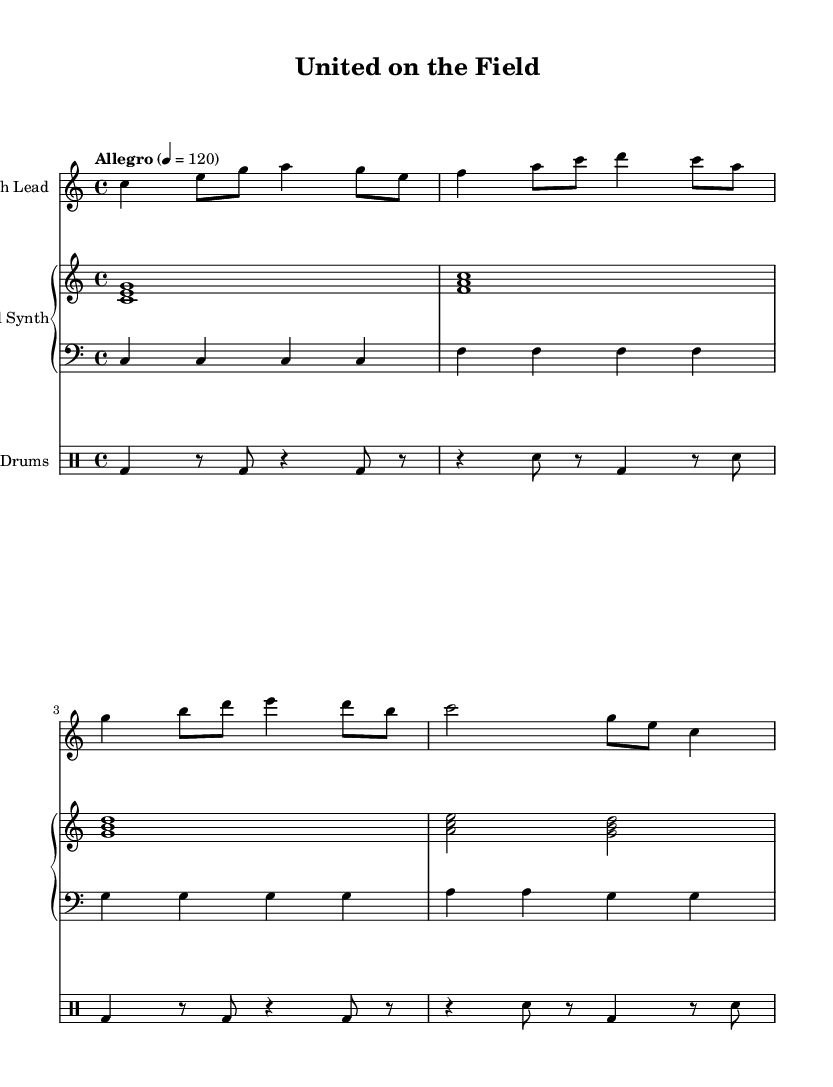What is the key signature of this music? The key signature is C major, which indicates there are no sharps or flats in the music. You can identify this by looking at the key signature section at the beginning of the music sheet.
Answer: C major What is the time signature of this composition? The time signature is 4/4, meaning there are four beats in each measure and the quarter note gets one beat. This can be found at the beginning of the piece, next to the key signature.
Answer: 4/4 What is the tempo marking for this piece? The tempo marking is "Allegro" indicating a fast tempo, specifically a speed of 120 beats per minute. This is specified at the beginning of the score.
Answer: Allegro, 120 How many measures are in the melody? The melody consists of four measures, which can be counted by the vertical bar lines that separate the measures within the score.
Answer: 4 What is the highest note in the melody part? The highest note in the melody is A, which appears in the first measure. To find this, look for the note lines and spaces, identifying the highest position of the melody notes.
Answer: A What instrument is responsible for the harmony in this piece? The harmony is played by the Pad Synth, as specified in the instrument name above the corresponding staff.
Answer: Pad Synth How do the bass notes connect with the melody? The bass notes provide a foundation by playing the root notes of the chords that align with the melody, reinforcing the harmonic structure. By matching the rhythm of the bass with the melody, we achieve a cohesive sound.
Answer: They provide harmony 